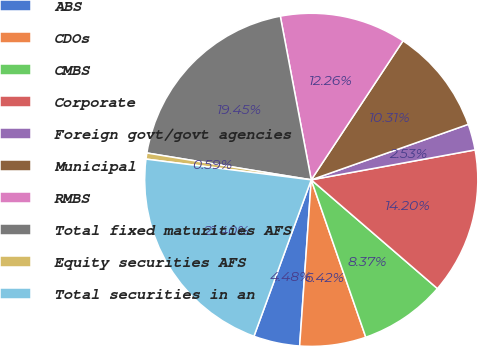<chart> <loc_0><loc_0><loc_500><loc_500><pie_chart><fcel>ABS<fcel>CDOs<fcel>CMBS<fcel>Corporate<fcel>Foreign govt/govt agencies<fcel>Municipal<fcel>RMBS<fcel>Total fixed maturities AFS<fcel>Equity securities AFS<fcel>Total securities in an<nl><fcel>4.48%<fcel>6.42%<fcel>8.37%<fcel>14.2%<fcel>2.53%<fcel>10.31%<fcel>12.26%<fcel>19.45%<fcel>0.59%<fcel>21.4%<nl></chart> 